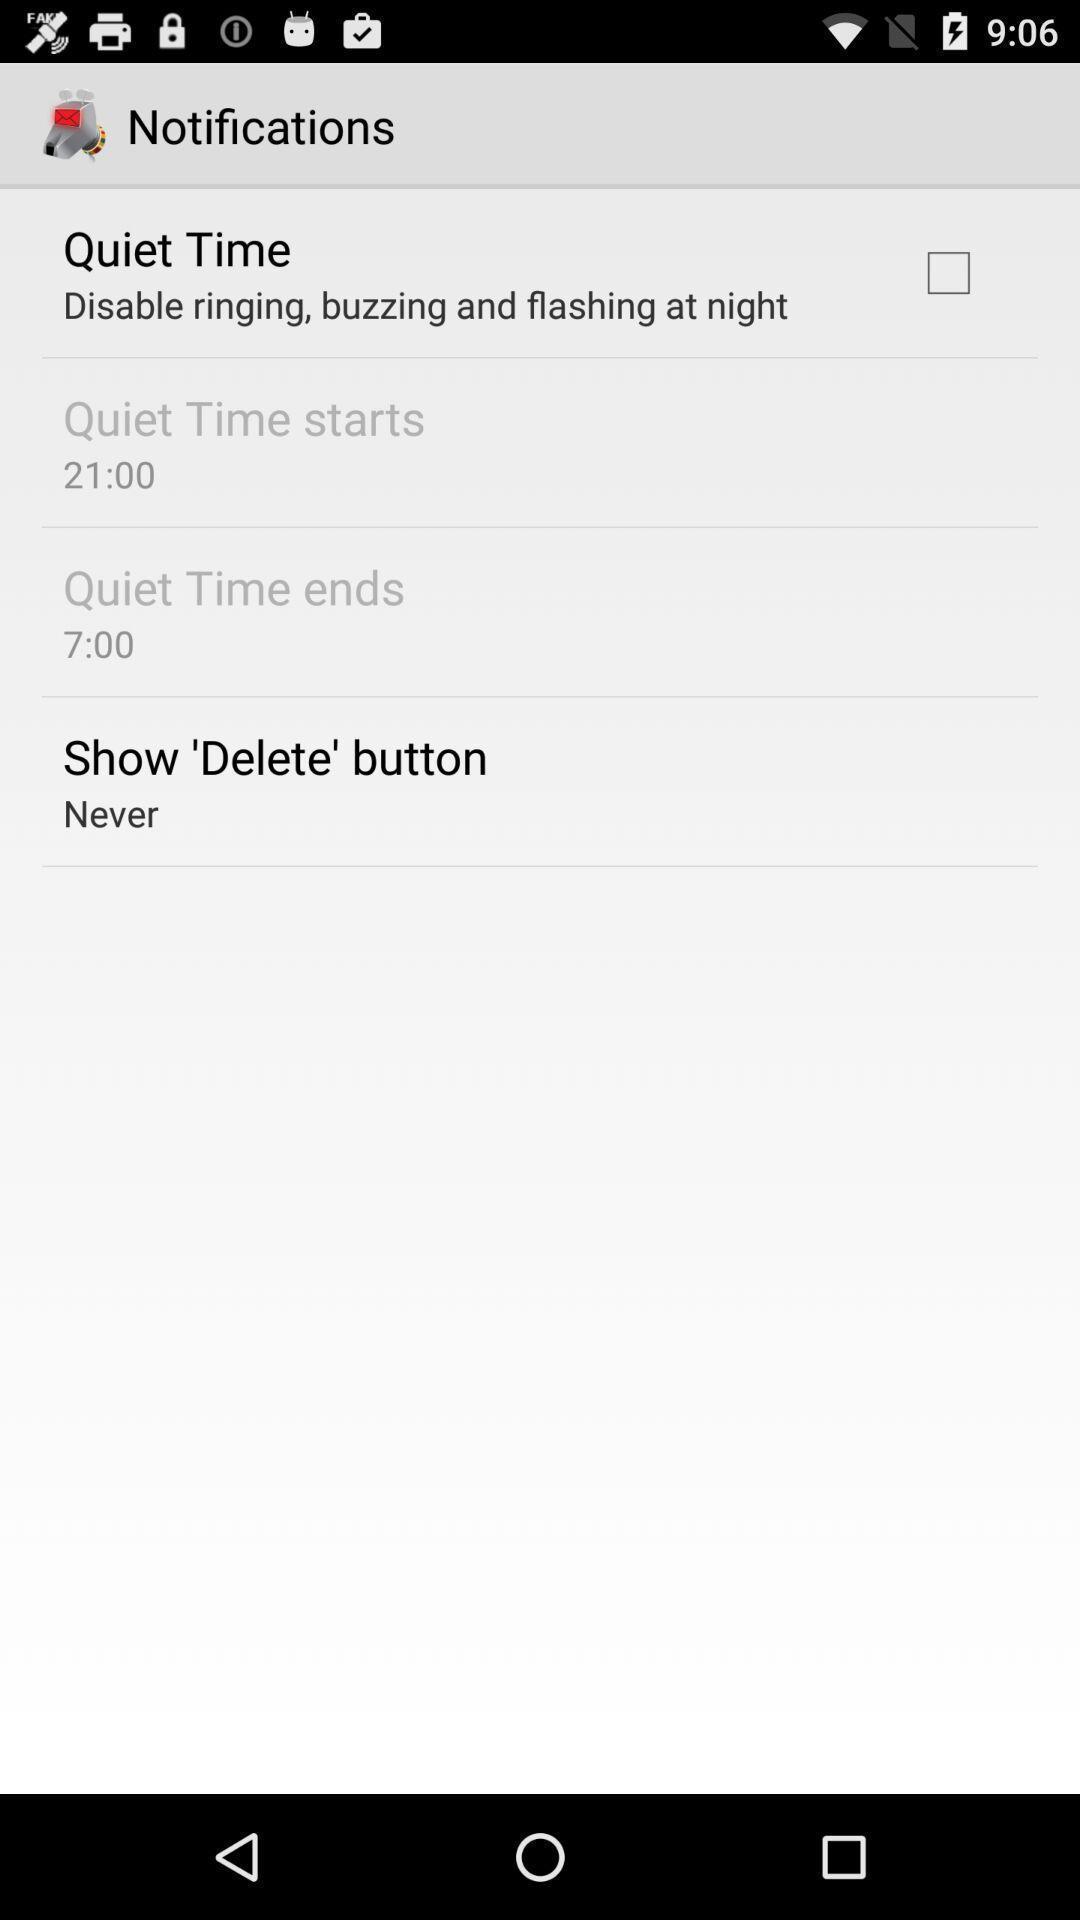Describe the visual elements of this screenshot. Screen displaying list of settings. 